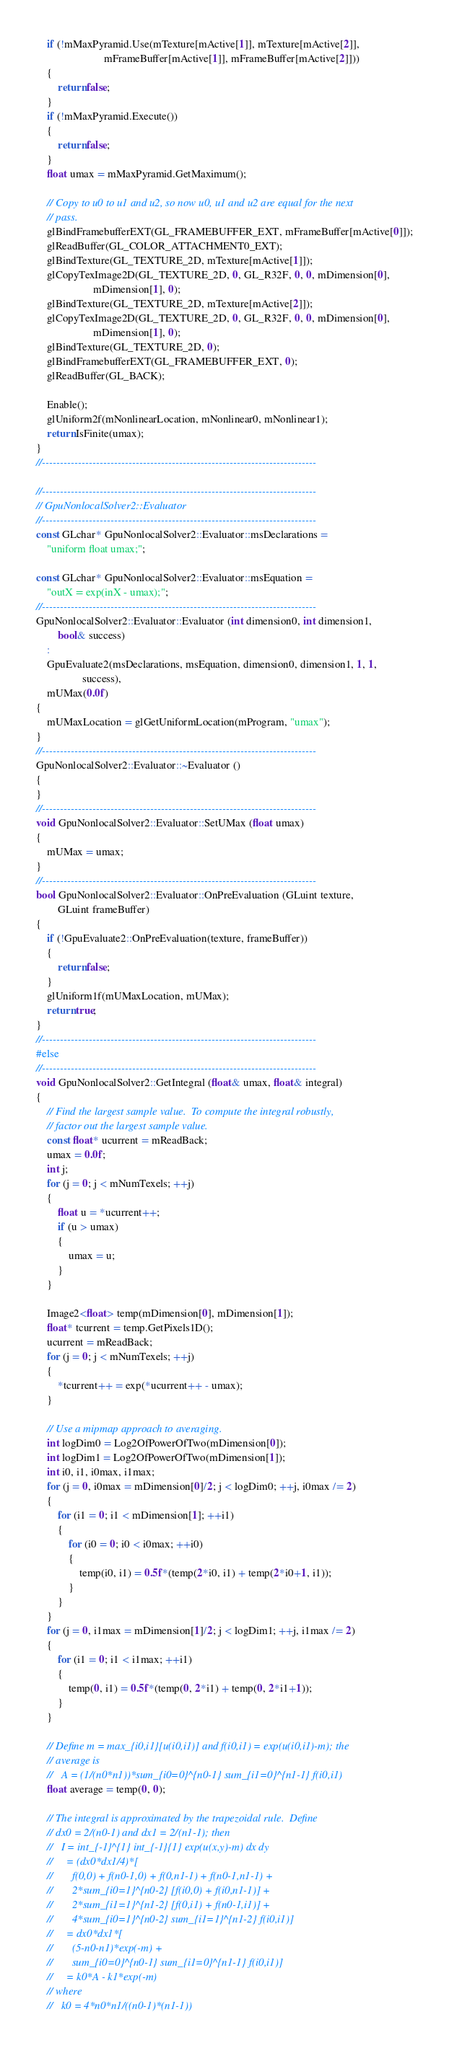<code> <loc_0><loc_0><loc_500><loc_500><_C++_>	if (!mMaxPyramid.Use(mTexture[mActive[1]], mTexture[mActive[2]],
	                     mFrameBuffer[mActive[1]], mFrameBuffer[mActive[2]]))
	{
		return false;
	}
	if (!mMaxPyramid.Execute())
	{
		return false;
	}
	float umax = mMaxPyramid.GetMaximum();

	// Copy to u0 to u1 and u2, so now u0, u1 and u2 are equal for the next
	// pass.
	glBindFramebufferEXT(GL_FRAMEBUFFER_EXT, mFrameBuffer[mActive[0]]);
	glReadBuffer(GL_COLOR_ATTACHMENT0_EXT);
	glBindTexture(GL_TEXTURE_2D, mTexture[mActive[1]]);
	glCopyTexImage2D(GL_TEXTURE_2D, 0, GL_R32F, 0, 0, mDimension[0],
	                 mDimension[1], 0);
	glBindTexture(GL_TEXTURE_2D, mTexture[mActive[2]]);
	glCopyTexImage2D(GL_TEXTURE_2D, 0, GL_R32F, 0, 0, mDimension[0],
	                 mDimension[1], 0);
	glBindTexture(GL_TEXTURE_2D, 0);
	glBindFramebufferEXT(GL_FRAMEBUFFER_EXT, 0);
	glReadBuffer(GL_BACK);

	Enable();
	glUniform2f(mNonlinearLocation, mNonlinear0, mNonlinear1);
	return IsFinite(umax);
}
//----------------------------------------------------------------------------

//----------------------------------------------------------------------------
// GpuNonlocalSolver2::Evaluator
//----------------------------------------------------------------------------
const GLchar* GpuNonlocalSolver2::Evaluator::msDeclarations =
    "uniform float umax;";

const GLchar* GpuNonlocalSolver2::Evaluator::msEquation =
    "outX = exp(inX - umax);";
//----------------------------------------------------------------------------
GpuNonlocalSolver2::Evaluator::Evaluator (int dimension0, int dimension1,
        bool& success)
	:
	GpuEvaluate2(msDeclarations, msEquation, dimension0, dimension1, 1, 1,
	             success),
	mUMax(0.0f)
{
	mUMaxLocation = glGetUniformLocation(mProgram, "umax");
}
//----------------------------------------------------------------------------
GpuNonlocalSolver2::Evaluator::~Evaluator ()
{
}
//----------------------------------------------------------------------------
void GpuNonlocalSolver2::Evaluator::SetUMax (float umax)
{
	mUMax = umax;
}
//----------------------------------------------------------------------------
bool GpuNonlocalSolver2::Evaluator::OnPreEvaluation (GLuint texture,
        GLuint frameBuffer)
{
	if (!GpuEvaluate2::OnPreEvaluation(texture, frameBuffer))
	{
		return false;
	}
	glUniform1f(mUMaxLocation, mUMax);
	return true;
}
//----------------------------------------------------------------------------
#else
//----------------------------------------------------------------------------
void GpuNonlocalSolver2::GetIntegral (float& umax, float& integral)
{
	// Find the largest sample value.  To compute the integral robustly,
	// factor out the largest sample value.
	const float* ucurrent = mReadBack;
	umax = 0.0f;
	int j;
	for (j = 0; j < mNumTexels; ++j)
	{
		float u = *ucurrent++;
		if (u > umax)
		{
			umax = u;
		}
	}

	Image2<float> temp(mDimension[0], mDimension[1]);
	float* tcurrent = temp.GetPixels1D();
	ucurrent = mReadBack;
	for (j = 0; j < mNumTexels; ++j)
	{
		*tcurrent++ = exp(*ucurrent++ - umax);
	}

	// Use a mipmap approach to averaging.
	int logDim0 = Log2OfPowerOfTwo(mDimension[0]);
	int logDim1 = Log2OfPowerOfTwo(mDimension[1]);
	int i0, i1, i0max, i1max;
	for (j = 0, i0max = mDimension[0]/2; j < logDim0; ++j, i0max /= 2)
	{
		for (i1 = 0; i1 < mDimension[1]; ++i1)
		{
			for (i0 = 0; i0 < i0max; ++i0)
			{
				temp(i0, i1) = 0.5f*(temp(2*i0, i1) + temp(2*i0+1, i1));
			}
		}
	}
	for (j = 0, i1max = mDimension[1]/2; j < logDim1; ++j, i1max /= 2)
	{
		for (i1 = 0; i1 < i1max; ++i1)
		{
			temp(0, i1) = 0.5f*(temp(0, 2*i1) + temp(0, 2*i1+1));
		}
	}

	// Define m = max_{i0,i1}[u(i0,i1)] and f(i0,i1) = exp(u(i0,i1)-m); the
	// average is
	//   A = (1/(n0*n1))*sum_{i0=0}^{n0-1} sum_{i1=0}^{n1-1} f(i0,i1)
	float average = temp(0, 0);

	// The integral is approximated by the trapezoidal rule.  Define
	// dx0 = 2/(n0-1) and dx1 = 2/(n1-1); then
	//   I = int_{-1}^{1} int_{-1}{1} exp(u(x,y)-m) dx dy
	//     = (dx0*dx1/4)*[
	//       f(0,0) + f(n0-1,0) + f(0,n1-1) + f(n0-1,n1-1) +
	//       2*sum_{i0=1}^{n0-2} [f(i0,0) + f(i0,n1-1)] +
	//       2*sum_{i1=1}^{n1-2} [f(0,i1) + f(n0-1,i1)] +
	//       4*sum_{i0=1}^{n0-2} sum_{i1=1}^{n1-2} f(i0,i1)]
	//     = dx0*dx1*[
	//       (5-n0-n1)*exp(-m) +
	//       sum_{i0=0}^{n0-1} sum_{i1=0}^{n1-1} f(i0,i1)]
	//     = k0*A - k1*exp(-m)
	// where
	//   k0 = 4*n0*n1/((n0-1)*(n1-1))</code> 